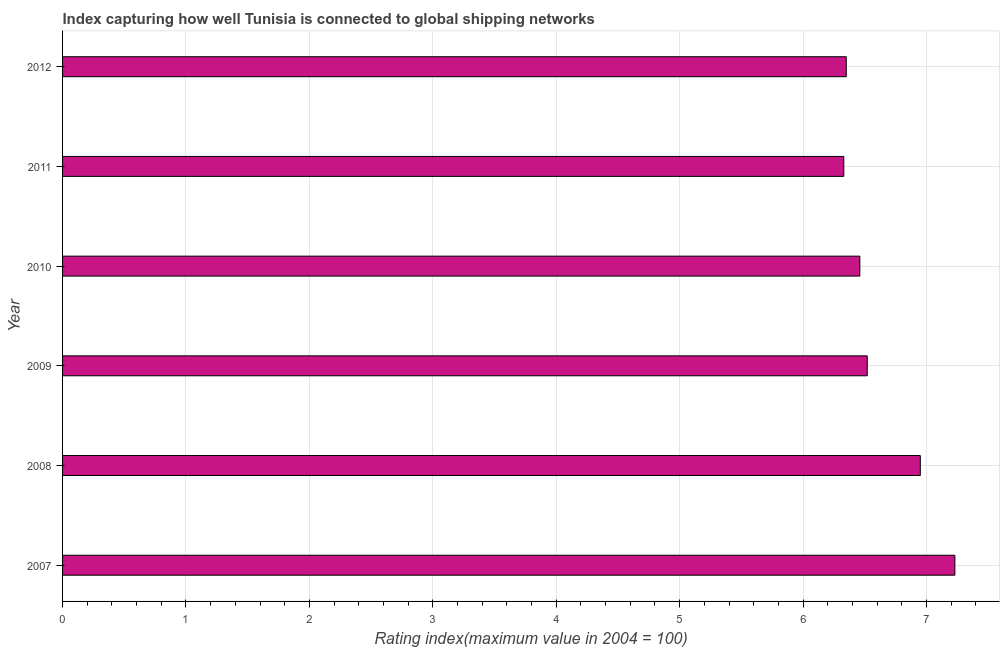Does the graph contain any zero values?
Ensure brevity in your answer.  No. What is the title of the graph?
Provide a succinct answer. Index capturing how well Tunisia is connected to global shipping networks. What is the label or title of the X-axis?
Offer a very short reply. Rating index(maximum value in 2004 = 100). What is the label or title of the Y-axis?
Offer a very short reply. Year. What is the liner shipping connectivity index in 2011?
Keep it short and to the point. 6.33. Across all years, what is the maximum liner shipping connectivity index?
Offer a terse response. 7.23. Across all years, what is the minimum liner shipping connectivity index?
Make the answer very short. 6.33. What is the sum of the liner shipping connectivity index?
Offer a terse response. 39.84. What is the difference between the liner shipping connectivity index in 2007 and 2011?
Your answer should be compact. 0.9. What is the average liner shipping connectivity index per year?
Offer a terse response. 6.64. What is the median liner shipping connectivity index?
Your response must be concise. 6.49. Do a majority of the years between 2008 and 2007 (inclusive) have liner shipping connectivity index greater than 2 ?
Provide a short and direct response. No. What is the difference between the highest and the second highest liner shipping connectivity index?
Give a very brief answer. 0.28. In how many years, is the liner shipping connectivity index greater than the average liner shipping connectivity index taken over all years?
Your response must be concise. 2. How many bars are there?
Provide a succinct answer. 6. What is the difference between two consecutive major ticks on the X-axis?
Ensure brevity in your answer.  1. What is the Rating index(maximum value in 2004 = 100) in 2007?
Your answer should be very brief. 7.23. What is the Rating index(maximum value in 2004 = 100) in 2008?
Your answer should be compact. 6.95. What is the Rating index(maximum value in 2004 = 100) in 2009?
Give a very brief answer. 6.52. What is the Rating index(maximum value in 2004 = 100) in 2010?
Provide a succinct answer. 6.46. What is the Rating index(maximum value in 2004 = 100) in 2011?
Your answer should be very brief. 6.33. What is the Rating index(maximum value in 2004 = 100) in 2012?
Your answer should be very brief. 6.35. What is the difference between the Rating index(maximum value in 2004 = 100) in 2007 and 2008?
Ensure brevity in your answer.  0.28. What is the difference between the Rating index(maximum value in 2004 = 100) in 2007 and 2009?
Offer a terse response. 0.71. What is the difference between the Rating index(maximum value in 2004 = 100) in 2007 and 2010?
Your response must be concise. 0.77. What is the difference between the Rating index(maximum value in 2004 = 100) in 2007 and 2011?
Provide a short and direct response. 0.9. What is the difference between the Rating index(maximum value in 2004 = 100) in 2008 and 2009?
Your answer should be very brief. 0.43. What is the difference between the Rating index(maximum value in 2004 = 100) in 2008 and 2010?
Your answer should be compact. 0.49. What is the difference between the Rating index(maximum value in 2004 = 100) in 2008 and 2011?
Give a very brief answer. 0.62. What is the difference between the Rating index(maximum value in 2004 = 100) in 2009 and 2011?
Your answer should be compact. 0.19. What is the difference between the Rating index(maximum value in 2004 = 100) in 2009 and 2012?
Ensure brevity in your answer.  0.17. What is the difference between the Rating index(maximum value in 2004 = 100) in 2010 and 2011?
Provide a short and direct response. 0.13. What is the difference between the Rating index(maximum value in 2004 = 100) in 2010 and 2012?
Your answer should be compact. 0.11. What is the difference between the Rating index(maximum value in 2004 = 100) in 2011 and 2012?
Your response must be concise. -0.02. What is the ratio of the Rating index(maximum value in 2004 = 100) in 2007 to that in 2008?
Make the answer very short. 1.04. What is the ratio of the Rating index(maximum value in 2004 = 100) in 2007 to that in 2009?
Offer a terse response. 1.11. What is the ratio of the Rating index(maximum value in 2004 = 100) in 2007 to that in 2010?
Your answer should be compact. 1.12. What is the ratio of the Rating index(maximum value in 2004 = 100) in 2007 to that in 2011?
Keep it short and to the point. 1.14. What is the ratio of the Rating index(maximum value in 2004 = 100) in 2007 to that in 2012?
Your answer should be very brief. 1.14. What is the ratio of the Rating index(maximum value in 2004 = 100) in 2008 to that in 2009?
Offer a very short reply. 1.07. What is the ratio of the Rating index(maximum value in 2004 = 100) in 2008 to that in 2010?
Provide a succinct answer. 1.08. What is the ratio of the Rating index(maximum value in 2004 = 100) in 2008 to that in 2011?
Your response must be concise. 1.1. What is the ratio of the Rating index(maximum value in 2004 = 100) in 2008 to that in 2012?
Make the answer very short. 1.09. What is the ratio of the Rating index(maximum value in 2004 = 100) in 2009 to that in 2010?
Make the answer very short. 1.01. What is the ratio of the Rating index(maximum value in 2004 = 100) in 2009 to that in 2011?
Offer a very short reply. 1.03. What is the ratio of the Rating index(maximum value in 2004 = 100) in 2009 to that in 2012?
Ensure brevity in your answer.  1.03. What is the ratio of the Rating index(maximum value in 2004 = 100) in 2010 to that in 2011?
Provide a short and direct response. 1.02. 